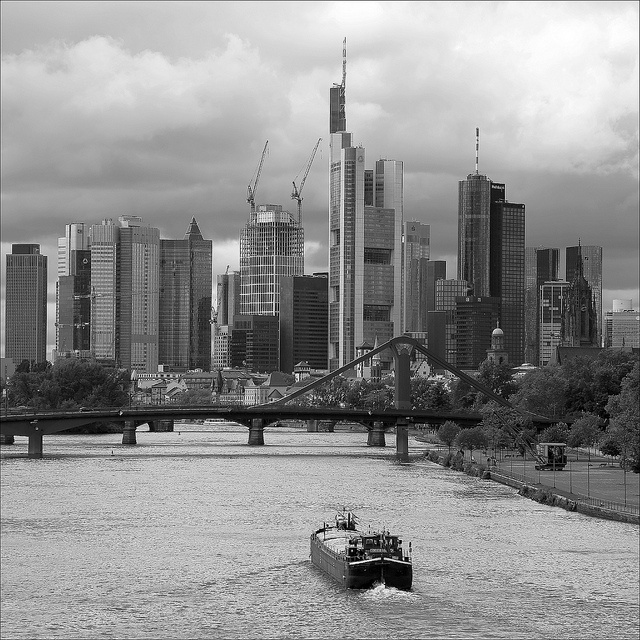Describe the objects in this image and their specific colors. I can see boat in black, gray, darkgray, and lightgray tones and truck in black, gray, and lightgray tones in this image. 